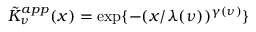Convert formula to latex. <formula><loc_0><loc_0><loc_500><loc_500>\tilde { K } _ { \nu } ^ { a p p } ( x ) = \exp \{ - ( x / \lambda ( \nu ) ) ^ { \gamma ( \nu ) } \}</formula> 